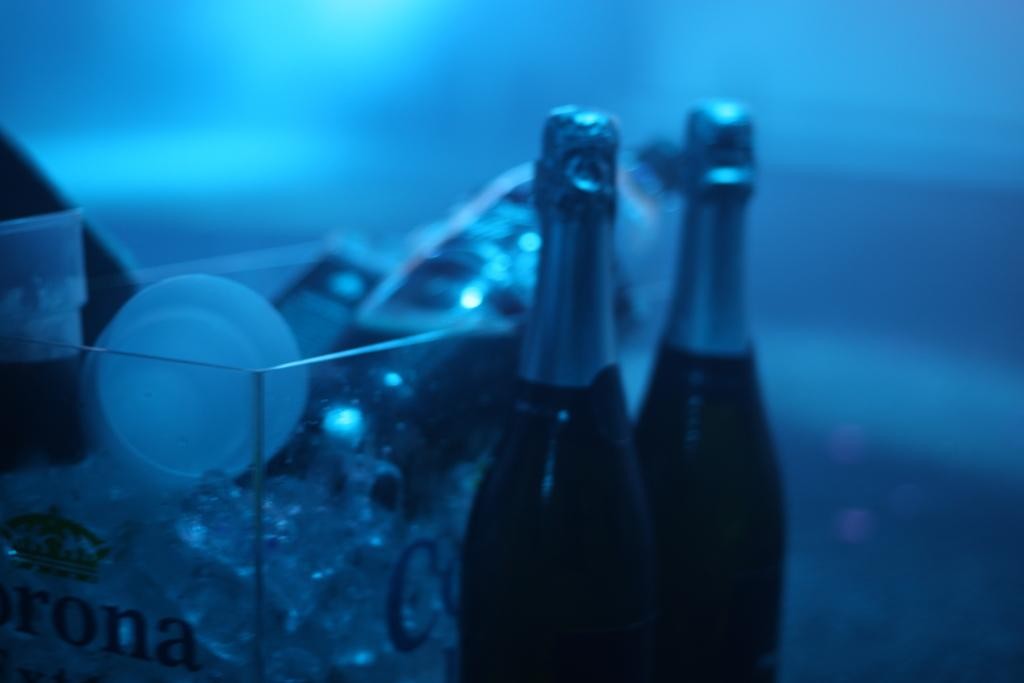Provide a one-sentence caption for the provided image. Two bottles of champagne and a glass bucket with Corona. 